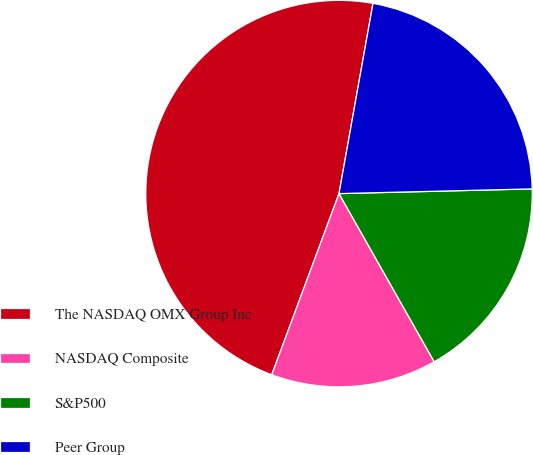<chart> <loc_0><loc_0><loc_500><loc_500><pie_chart><fcel>The NASDAQ OMX Group Inc<fcel>NASDAQ Composite<fcel>S&P500<fcel>Peer Group<nl><fcel>47.16%<fcel>13.86%<fcel>17.19%<fcel>21.8%<nl></chart> 